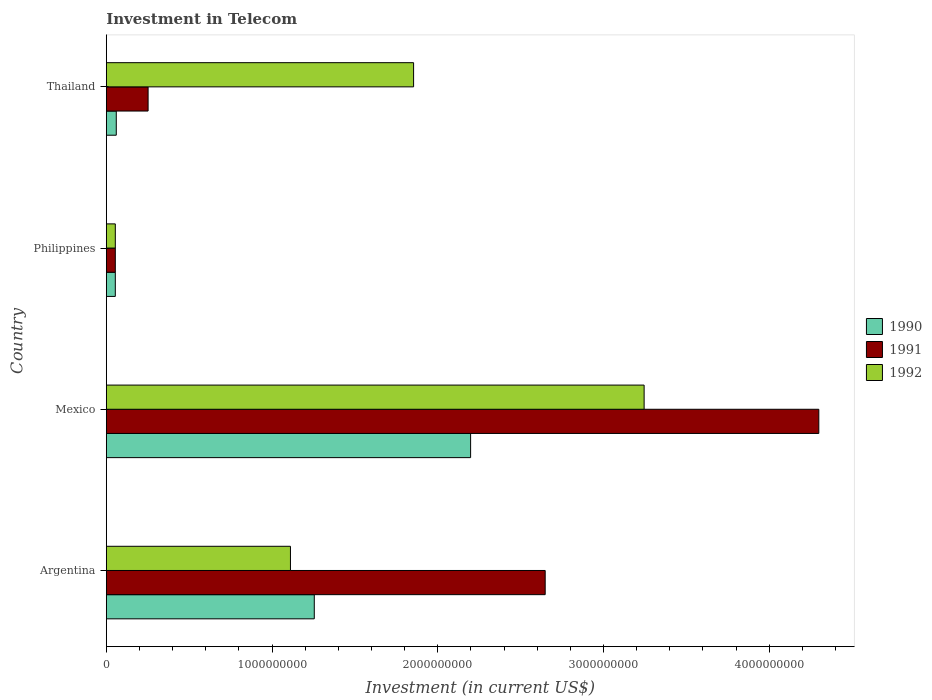Are the number of bars per tick equal to the number of legend labels?
Offer a very short reply. Yes. Are the number of bars on each tick of the Y-axis equal?
Provide a short and direct response. Yes. In how many cases, is the number of bars for a given country not equal to the number of legend labels?
Keep it short and to the point. 0. What is the amount invested in telecom in 1992 in Philippines?
Offer a terse response. 5.42e+07. Across all countries, what is the maximum amount invested in telecom in 1991?
Your response must be concise. 4.30e+09. Across all countries, what is the minimum amount invested in telecom in 1992?
Your answer should be very brief. 5.42e+07. In which country was the amount invested in telecom in 1990 minimum?
Make the answer very short. Philippines. What is the total amount invested in telecom in 1990 in the graph?
Offer a terse response. 3.57e+09. What is the difference between the amount invested in telecom in 1991 in Argentina and that in Philippines?
Your answer should be very brief. 2.59e+09. What is the difference between the amount invested in telecom in 1990 in Philippines and the amount invested in telecom in 1992 in Mexico?
Your answer should be very brief. -3.19e+09. What is the average amount invested in telecom in 1992 per country?
Provide a succinct answer. 1.57e+09. What is the difference between the amount invested in telecom in 1991 and amount invested in telecom in 1992 in Thailand?
Offer a very short reply. -1.60e+09. What is the ratio of the amount invested in telecom in 1990 in Argentina to that in Philippines?
Provide a short and direct response. 23.15. Is the difference between the amount invested in telecom in 1991 in Mexico and Thailand greater than the difference between the amount invested in telecom in 1992 in Mexico and Thailand?
Provide a succinct answer. Yes. What is the difference between the highest and the second highest amount invested in telecom in 1992?
Your answer should be compact. 1.39e+09. What is the difference between the highest and the lowest amount invested in telecom in 1990?
Your answer should be compact. 2.14e+09. What does the 3rd bar from the top in Thailand represents?
Offer a terse response. 1990. How many bars are there?
Ensure brevity in your answer.  12. Are all the bars in the graph horizontal?
Ensure brevity in your answer.  Yes. How many countries are there in the graph?
Keep it short and to the point. 4. Are the values on the major ticks of X-axis written in scientific E-notation?
Make the answer very short. No. Does the graph contain any zero values?
Offer a very short reply. No. How many legend labels are there?
Provide a short and direct response. 3. What is the title of the graph?
Provide a short and direct response. Investment in Telecom. Does "2003" appear as one of the legend labels in the graph?
Your answer should be compact. No. What is the label or title of the X-axis?
Give a very brief answer. Investment (in current US$). What is the Investment (in current US$) of 1990 in Argentina?
Keep it short and to the point. 1.25e+09. What is the Investment (in current US$) of 1991 in Argentina?
Ensure brevity in your answer.  2.65e+09. What is the Investment (in current US$) of 1992 in Argentina?
Give a very brief answer. 1.11e+09. What is the Investment (in current US$) of 1990 in Mexico?
Offer a terse response. 2.20e+09. What is the Investment (in current US$) of 1991 in Mexico?
Ensure brevity in your answer.  4.30e+09. What is the Investment (in current US$) in 1992 in Mexico?
Your answer should be compact. 3.24e+09. What is the Investment (in current US$) of 1990 in Philippines?
Your answer should be compact. 5.42e+07. What is the Investment (in current US$) of 1991 in Philippines?
Make the answer very short. 5.42e+07. What is the Investment (in current US$) in 1992 in Philippines?
Provide a short and direct response. 5.42e+07. What is the Investment (in current US$) in 1990 in Thailand?
Ensure brevity in your answer.  6.00e+07. What is the Investment (in current US$) in 1991 in Thailand?
Make the answer very short. 2.52e+08. What is the Investment (in current US$) in 1992 in Thailand?
Keep it short and to the point. 1.85e+09. Across all countries, what is the maximum Investment (in current US$) in 1990?
Offer a very short reply. 2.20e+09. Across all countries, what is the maximum Investment (in current US$) in 1991?
Offer a terse response. 4.30e+09. Across all countries, what is the maximum Investment (in current US$) in 1992?
Provide a succinct answer. 3.24e+09. Across all countries, what is the minimum Investment (in current US$) in 1990?
Offer a terse response. 5.42e+07. Across all countries, what is the minimum Investment (in current US$) in 1991?
Provide a succinct answer. 5.42e+07. Across all countries, what is the minimum Investment (in current US$) of 1992?
Offer a very short reply. 5.42e+07. What is the total Investment (in current US$) of 1990 in the graph?
Your answer should be very brief. 3.57e+09. What is the total Investment (in current US$) of 1991 in the graph?
Offer a terse response. 7.25e+09. What is the total Investment (in current US$) of 1992 in the graph?
Make the answer very short. 6.26e+09. What is the difference between the Investment (in current US$) in 1990 in Argentina and that in Mexico?
Provide a succinct answer. -9.43e+08. What is the difference between the Investment (in current US$) of 1991 in Argentina and that in Mexico?
Ensure brevity in your answer.  -1.65e+09. What is the difference between the Investment (in current US$) of 1992 in Argentina and that in Mexico?
Provide a succinct answer. -2.13e+09. What is the difference between the Investment (in current US$) of 1990 in Argentina and that in Philippines?
Your response must be concise. 1.20e+09. What is the difference between the Investment (in current US$) of 1991 in Argentina and that in Philippines?
Provide a succinct answer. 2.59e+09. What is the difference between the Investment (in current US$) in 1992 in Argentina and that in Philippines?
Offer a terse response. 1.06e+09. What is the difference between the Investment (in current US$) in 1990 in Argentina and that in Thailand?
Provide a succinct answer. 1.19e+09. What is the difference between the Investment (in current US$) in 1991 in Argentina and that in Thailand?
Keep it short and to the point. 2.40e+09. What is the difference between the Investment (in current US$) in 1992 in Argentina and that in Thailand?
Ensure brevity in your answer.  -7.43e+08. What is the difference between the Investment (in current US$) in 1990 in Mexico and that in Philippines?
Ensure brevity in your answer.  2.14e+09. What is the difference between the Investment (in current US$) in 1991 in Mexico and that in Philippines?
Offer a very short reply. 4.24e+09. What is the difference between the Investment (in current US$) of 1992 in Mexico and that in Philippines?
Offer a very short reply. 3.19e+09. What is the difference between the Investment (in current US$) in 1990 in Mexico and that in Thailand?
Make the answer very short. 2.14e+09. What is the difference between the Investment (in current US$) of 1991 in Mexico and that in Thailand?
Offer a terse response. 4.05e+09. What is the difference between the Investment (in current US$) of 1992 in Mexico and that in Thailand?
Your answer should be very brief. 1.39e+09. What is the difference between the Investment (in current US$) in 1990 in Philippines and that in Thailand?
Provide a short and direct response. -5.80e+06. What is the difference between the Investment (in current US$) of 1991 in Philippines and that in Thailand?
Make the answer very short. -1.98e+08. What is the difference between the Investment (in current US$) in 1992 in Philippines and that in Thailand?
Make the answer very short. -1.80e+09. What is the difference between the Investment (in current US$) in 1990 in Argentina and the Investment (in current US$) in 1991 in Mexico?
Offer a terse response. -3.04e+09. What is the difference between the Investment (in current US$) in 1990 in Argentina and the Investment (in current US$) in 1992 in Mexico?
Keep it short and to the point. -1.99e+09. What is the difference between the Investment (in current US$) in 1991 in Argentina and the Investment (in current US$) in 1992 in Mexico?
Keep it short and to the point. -5.97e+08. What is the difference between the Investment (in current US$) of 1990 in Argentina and the Investment (in current US$) of 1991 in Philippines?
Make the answer very short. 1.20e+09. What is the difference between the Investment (in current US$) of 1990 in Argentina and the Investment (in current US$) of 1992 in Philippines?
Make the answer very short. 1.20e+09. What is the difference between the Investment (in current US$) in 1991 in Argentina and the Investment (in current US$) in 1992 in Philippines?
Ensure brevity in your answer.  2.59e+09. What is the difference between the Investment (in current US$) of 1990 in Argentina and the Investment (in current US$) of 1991 in Thailand?
Your answer should be very brief. 1.00e+09. What is the difference between the Investment (in current US$) of 1990 in Argentina and the Investment (in current US$) of 1992 in Thailand?
Offer a very short reply. -5.99e+08. What is the difference between the Investment (in current US$) in 1991 in Argentina and the Investment (in current US$) in 1992 in Thailand?
Provide a short and direct response. 7.94e+08. What is the difference between the Investment (in current US$) in 1990 in Mexico and the Investment (in current US$) in 1991 in Philippines?
Make the answer very short. 2.14e+09. What is the difference between the Investment (in current US$) in 1990 in Mexico and the Investment (in current US$) in 1992 in Philippines?
Offer a terse response. 2.14e+09. What is the difference between the Investment (in current US$) in 1991 in Mexico and the Investment (in current US$) in 1992 in Philippines?
Ensure brevity in your answer.  4.24e+09. What is the difference between the Investment (in current US$) of 1990 in Mexico and the Investment (in current US$) of 1991 in Thailand?
Offer a terse response. 1.95e+09. What is the difference between the Investment (in current US$) of 1990 in Mexico and the Investment (in current US$) of 1992 in Thailand?
Keep it short and to the point. 3.44e+08. What is the difference between the Investment (in current US$) in 1991 in Mexico and the Investment (in current US$) in 1992 in Thailand?
Your answer should be compact. 2.44e+09. What is the difference between the Investment (in current US$) in 1990 in Philippines and the Investment (in current US$) in 1991 in Thailand?
Offer a terse response. -1.98e+08. What is the difference between the Investment (in current US$) of 1990 in Philippines and the Investment (in current US$) of 1992 in Thailand?
Offer a terse response. -1.80e+09. What is the difference between the Investment (in current US$) in 1991 in Philippines and the Investment (in current US$) in 1992 in Thailand?
Your answer should be compact. -1.80e+09. What is the average Investment (in current US$) of 1990 per country?
Your answer should be very brief. 8.92e+08. What is the average Investment (in current US$) in 1991 per country?
Ensure brevity in your answer.  1.81e+09. What is the average Investment (in current US$) in 1992 per country?
Provide a short and direct response. 1.57e+09. What is the difference between the Investment (in current US$) of 1990 and Investment (in current US$) of 1991 in Argentina?
Keep it short and to the point. -1.39e+09. What is the difference between the Investment (in current US$) of 1990 and Investment (in current US$) of 1992 in Argentina?
Keep it short and to the point. 1.44e+08. What is the difference between the Investment (in current US$) of 1991 and Investment (in current US$) of 1992 in Argentina?
Offer a very short reply. 1.54e+09. What is the difference between the Investment (in current US$) in 1990 and Investment (in current US$) in 1991 in Mexico?
Give a very brief answer. -2.10e+09. What is the difference between the Investment (in current US$) of 1990 and Investment (in current US$) of 1992 in Mexico?
Offer a very short reply. -1.05e+09. What is the difference between the Investment (in current US$) of 1991 and Investment (in current US$) of 1992 in Mexico?
Provide a short and direct response. 1.05e+09. What is the difference between the Investment (in current US$) in 1990 and Investment (in current US$) in 1991 in Thailand?
Offer a very short reply. -1.92e+08. What is the difference between the Investment (in current US$) in 1990 and Investment (in current US$) in 1992 in Thailand?
Keep it short and to the point. -1.79e+09. What is the difference between the Investment (in current US$) in 1991 and Investment (in current US$) in 1992 in Thailand?
Give a very brief answer. -1.60e+09. What is the ratio of the Investment (in current US$) in 1990 in Argentina to that in Mexico?
Your answer should be compact. 0.57. What is the ratio of the Investment (in current US$) in 1991 in Argentina to that in Mexico?
Keep it short and to the point. 0.62. What is the ratio of the Investment (in current US$) in 1992 in Argentina to that in Mexico?
Make the answer very short. 0.34. What is the ratio of the Investment (in current US$) of 1990 in Argentina to that in Philippines?
Your answer should be very brief. 23.15. What is the ratio of the Investment (in current US$) of 1991 in Argentina to that in Philippines?
Provide a short and direct response. 48.86. What is the ratio of the Investment (in current US$) in 1992 in Argentina to that in Philippines?
Provide a short and direct response. 20.5. What is the ratio of the Investment (in current US$) in 1990 in Argentina to that in Thailand?
Your answer should be very brief. 20.91. What is the ratio of the Investment (in current US$) of 1991 in Argentina to that in Thailand?
Your answer should be compact. 10.51. What is the ratio of the Investment (in current US$) of 1992 in Argentina to that in Thailand?
Provide a short and direct response. 0.6. What is the ratio of the Investment (in current US$) of 1990 in Mexico to that in Philippines?
Make the answer very short. 40.55. What is the ratio of the Investment (in current US$) of 1991 in Mexico to that in Philippines?
Your response must be concise. 79.32. What is the ratio of the Investment (in current US$) in 1992 in Mexico to that in Philippines?
Offer a terse response. 59.87. What is the ratio of the Investment (in current US$) of 1990 in Mexico to that in Thailand?
Ensure brevity in your answer.  36.63. What is the ratio of the Investment (in current US$) in 1991 in Mexico to that in Thailand?
Your response must be concise. 17.06. What is the ratio of the Investment (in current US$) of 1992 in Mexico to that in Thailand?
Offer a terse response. 1.75. What is the ratio of the Investment (in current US$) of 1990 in Philippines to that in Thailand?
Make the answer very short. 0.9. What is the ratio of the Investment (in current US$) of 1991 in Philippines to that in Thailand?
Provide a short and direct response. 0.22. What is the ratio of the Investment (in current US$) of 1992 in Philippines to that in Thailand?
Provide a short and direct response. 0.03. What is the difference between the highest and the second highest Investment (in current US$) of 1990?
Keep it short and to the point. 9.43e+08. What is the difference between the highest and the second highest Investment (in current US$) in 1991?
Your response must be concise. 1.65e+09. What is the difference between the highest and the second highest Investment (in current US$) of 1992?
Your answer should be compact. 1.39e+09. What is the difference between the highest and the lowest Investment (in current US$) of 1990?
Your answer should be compact. 2.14e+09. What is the difference between the highest and the lowest Investment (in current US$) of 1991?
Give a very brief answer. 4.24e+09. What is the difference between the highest and the lowest Investment (in current US$) in 1992?
Your answer should be compact. 3.19e+09. 